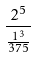Convert formula to latex. <formula><loc_0><loc_0><loc_500><loc_500>\frac { 2 ^ { 5 } } { \frac { 1 ^ { 3 } } { 3 7 5 } }</formula> 